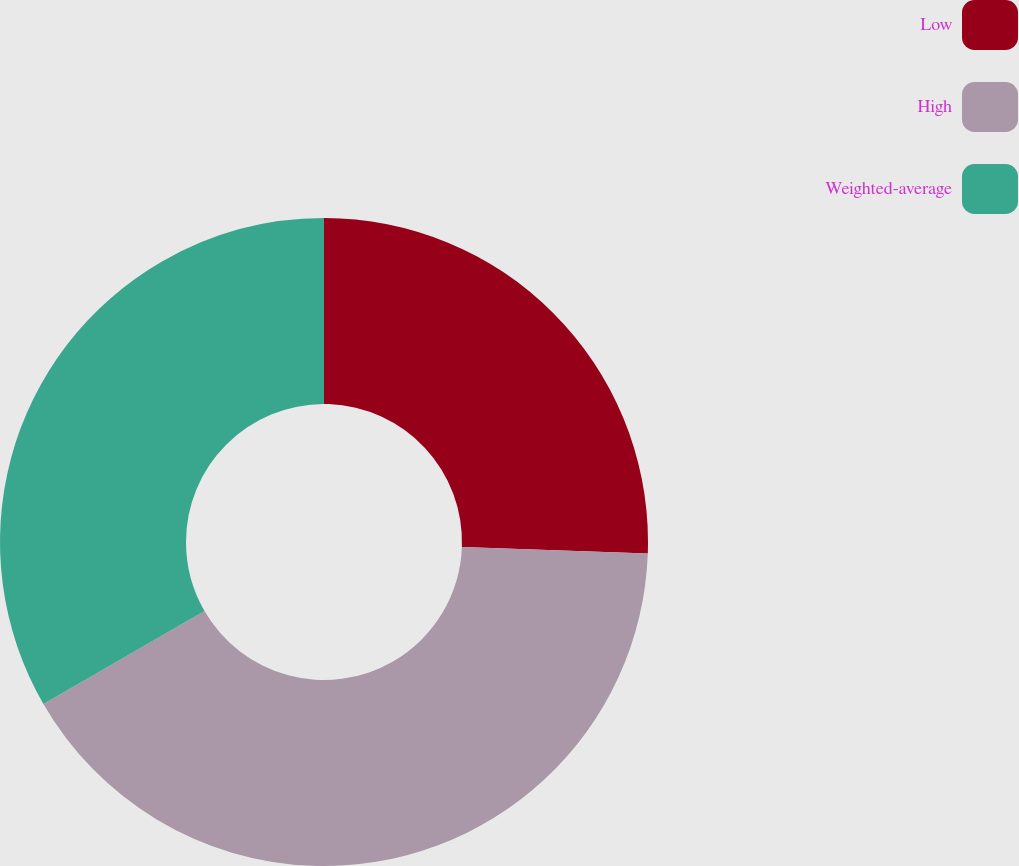Convert chart to OTSL. <chart><loc_0><loc_0><loc_500><loc_500><pie_chart><fcel>Low<fcel>High<fcel>Weighted-average<nl><fcel>25.56%<fcel>41.1%<fcel>33.33%<nl></chart> 